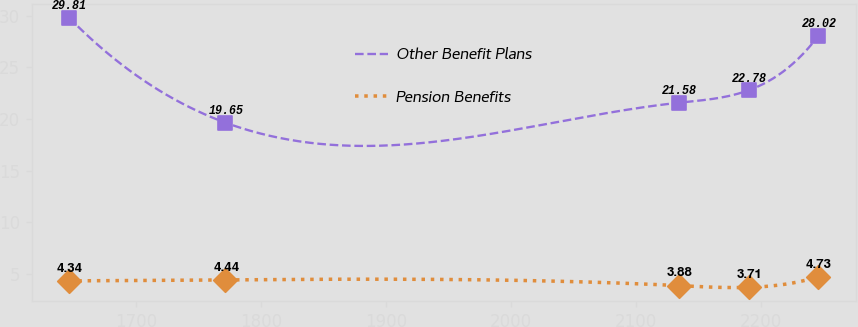Convert chart. <chart><loc_0><loc_0><loc_500><loc_500><line_chart><ecel><fcel>Other Benefit Plans<fcel>Pension Benefits<nl><fcel>1646.23<fcel>29.81<fcel>4.34<nl><fcel>1771.43<fcel>19.65<fcel>4.44<nl><fcel>2134.45<fcel>21.58<fcel>3.88<nl><fcel>2190.16<fcel>22.78<fcel>3.71<nl><fcel>2245.87<fcel>28.02<fcel>4.73<nl></chart> 